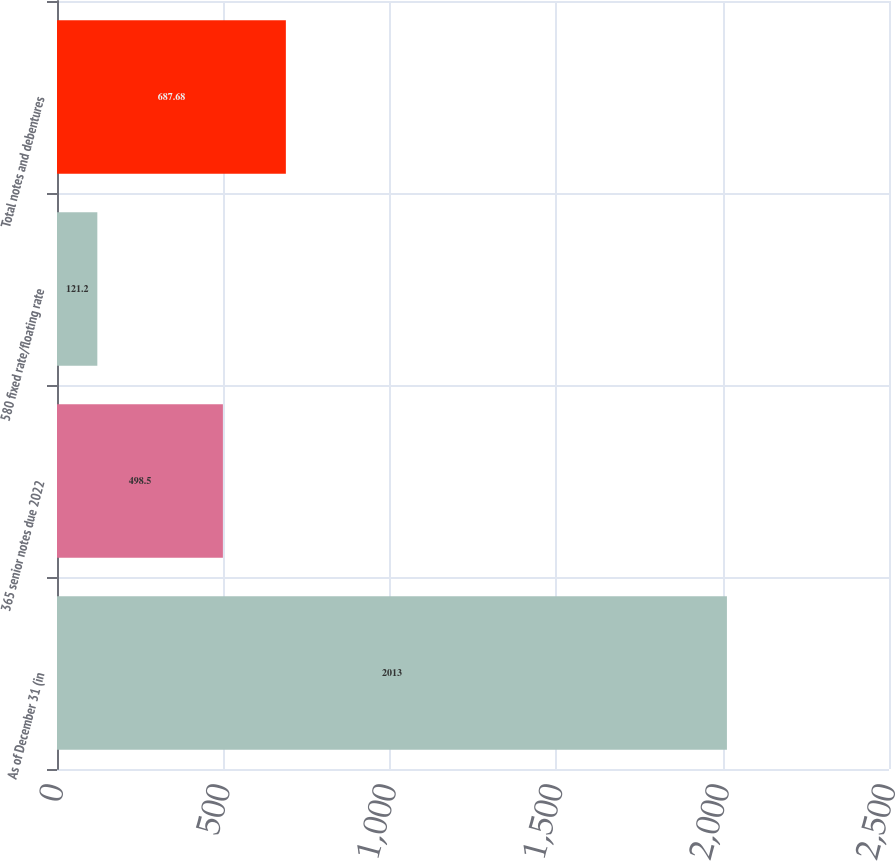<chart> <loc_0><loc_0><loc_500><loc_500><bar_chart><fcel>As of December 31 (in<fcel>365 senior notes due 2022<fcel>580 fixed rate/floating rate<fcel>Total notes and debentures<nl><fcel>2013<fcel>498.5<fcel>121.2<fcel>687.68<nl></chart> 